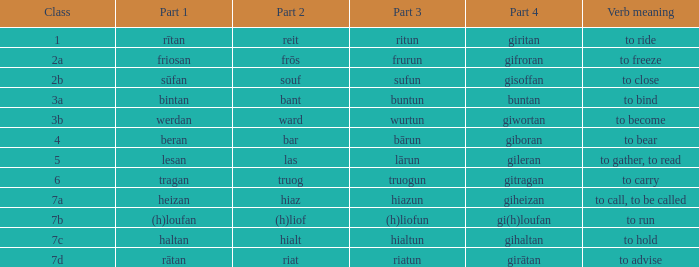What is the part 4 when part 1 is "lesan"? Gileran. 